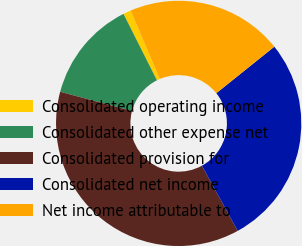Convert chart to OTSL. <chart><loc_0><loc_0><loc_500><loc_500><pie_chart><fcel>Consolidated operating income<fcel>Consolidated other expense net<fcel>Consolidated provision for<fcel>Consolidated net income<fcel>Net income attributable to<nl><fcel>1.03%<fcel>13.42%<fcel>37.15%<fcel>27.76%<fcel>20.64%<nl></chart> 